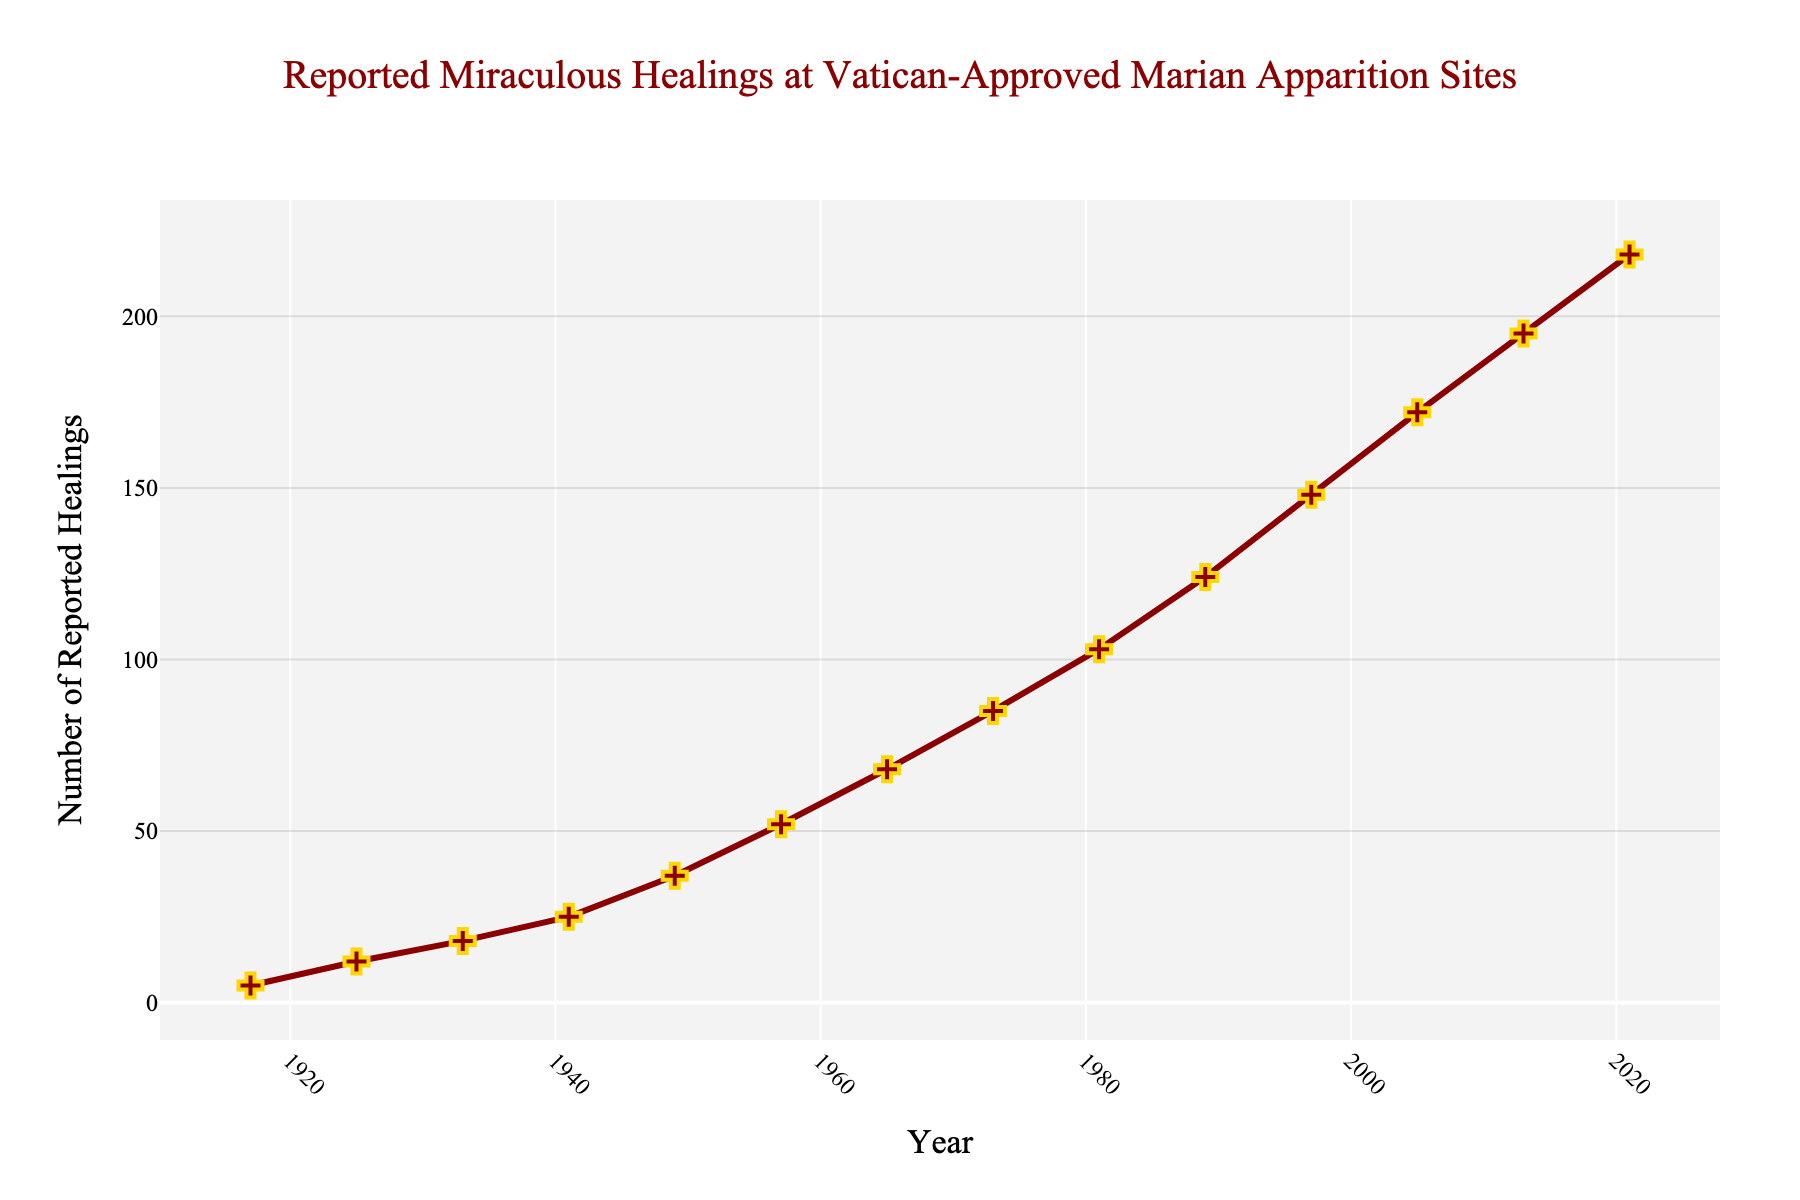What is the total number of reported miraculous healings from 1917 to 1941? Sum the values from 1917 to 1941: 5 (1917) + 12 (1925) + 18 (1933) + 25 (1941) = 60
Answer: 60 Between which two years was the largest increase in reported miraculous healings observed? Compare the incremental increase between each set of successive years: 
- 1917 to 1925: 12 - 5 = 7 
- 1925 to 1933: 18 - 12 = 6 
- 1933 to 1941: 25 - 18 = 7 
- 1941 to 1949: 37 - 25 = 12
- 1949 to 1957: 52 - 37 = 15
- 1957 to 1965: 68 - 52 = 16 
- 1965 to 1973: 85 - 68 = 17 
- 1973 to 1981: 103 - 85 = 18 
- 1981 to 1989: 124 - 103 = 21 
- 1989 to 1997: 148 - 124 = 24 
- 1997 to 2005: 172 - 148 = 24 
- 2005 to 2013: 195 - 172 = 23
- 2013 to 2021: 218 - 195 = 23
The largest increase is from 1989 to 1997 and from 1997 to 2005, both with an increase of 24
Answer: 1989 to 1997; 1997 to 2005 How does the slope of the line between 1965 and 1973 compare to the slope between 2005 and 2013? Calculate the slope for each interval:
- 1965 to 1973: (85 - 68) / (1973 - 1965) = 17 / 8 = 2.125
- 2005 to 2013: (195 - 172) / (2013 - 2005) = 23 / 8 = 2.875
The slope between 2005 and 2013 is steeper than between 1965 and 1973
Answer: Steeper What is the average number of reported miraculous healings per decade from the data provided? Identify the number of decades and sum the total number of reported healings, then divide by the number of decades:
- Sum of healings = 5 + 12 + 18 + 25 + 37 + 52 + 68 + 85 + 103 + 124 + 148 + 172 + 195 + 218 = 1262
- Number of decades = 10 (1917, 1925, 1933, 1941, 1949, 1957, 1965, 1973, 1981, 1989, 1997, 2005, 2013, 2021 are approximately spread over a century)
- Average = 1262 / 10 = 126.2
Answer: 126.2 Which year had a significant symbolic increase in line markers, and why might this be visually significant? Identify the year with a marked and visually significant increase:
- Consider when the markers are most noticeable, consulting changes between 1941 to 1949, and 1949 to 1957 as visually highlighted steps exceeding previous growth
1949 had an increase from 25 (1941) to 37(1949) marking a visual jump, again from 1957 to 1965; this doubling in reported healings can be tied to visually significant moments in the lines and markers that was steeper than predecessor intervals
Answer: 1949 and 1957 